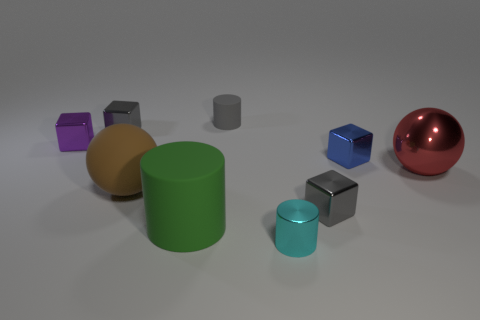Subtract all blue blocks. How many blocks are left? 3 Add 1 big brown blocks. How many objects exist? 10 Subtract all spheres. How many objects are left? 7 Add 2 tiny brown matte blocks. How many tiny brown matte blocks exist? 2 Subtract 1 blue cubes. How many objects are left? 8 Subtract all red things. Subtract all gray things. How many objects are left? 5 Add 8 large red objects. How many large red objects are left? 9 